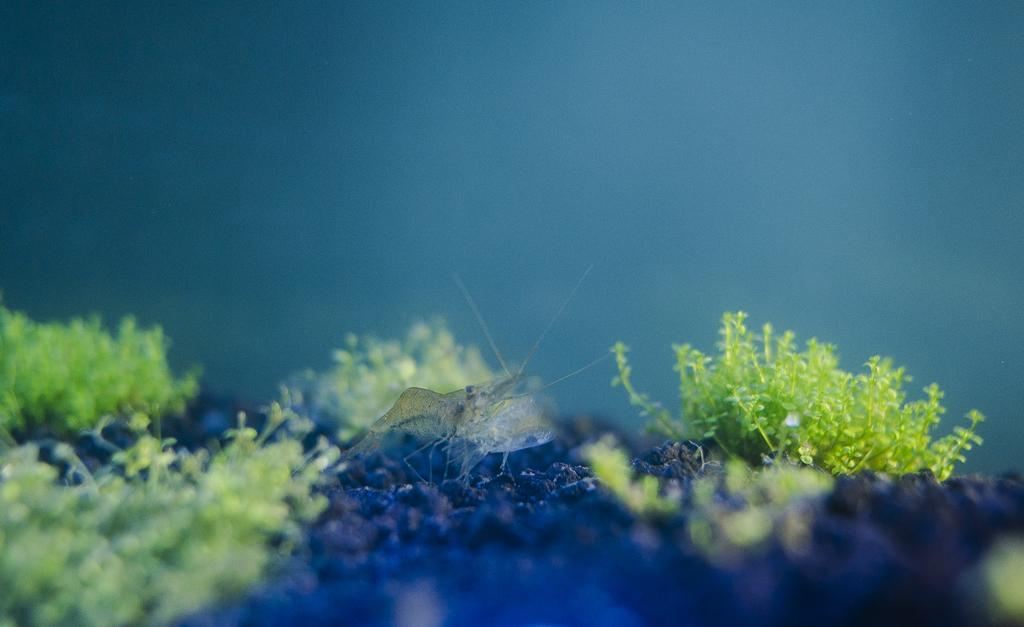What type of creature is in the image? There is an insect in the image. Where is the insect located? The insect is standing on the land. What can be seen on either side of the insect? There are small trees on either side of the insect. How would you describe the background of the image? The background of the image is blurred. How many baseballs can be seen in the image? There are no baseballs present in the image; it features an insect standing on the land with small trees on either side. 